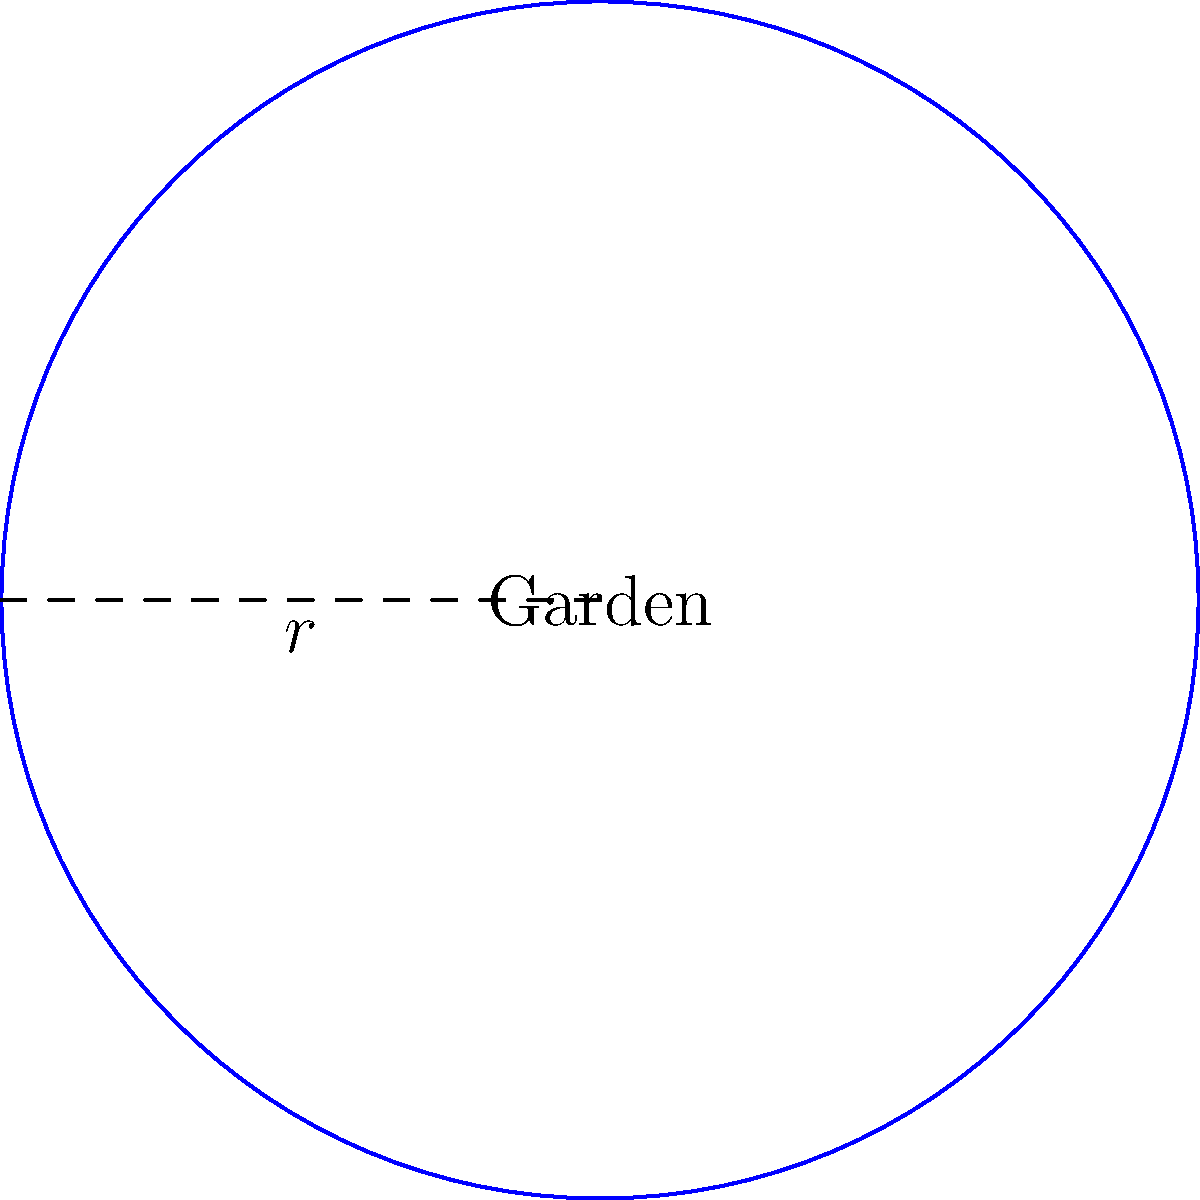A circular garden path has a radius of 15 meters. If you want to walk 3 laps around the garden for your daily exercise, what is the total distance you will walk in kilometers? Let's break this down step-by-step:

1) First, we need to calculate the circumference of the circular path.
   The formula for circumference is: $C = 2\pi r$
   Where $r$ is the radius.

2) Plugging in our radius of 15 meters:
   $C = 2\pi(15) = 30\pi$ meters

3) Now, we need to multiply this by 3 laps:
   Total distance = $3 * 30\pi = 90\pi$ meters

4) To convert this to kilometers, we divide by 1000:
   Distance in km = $\frac{90\pi}{1000} = 0.09\pi$ km

5) Using a calculator or approximating $\pi$ as 3.14159:
   $0.09\pi \approx 0.282743$ km

6) Rounding to three decimal places for a reasonable level of precision:
   $0.283$ km

This distance is suitable for a short, manageable walk for an elderly person with complex medical history.
Answer: 0.283 km 